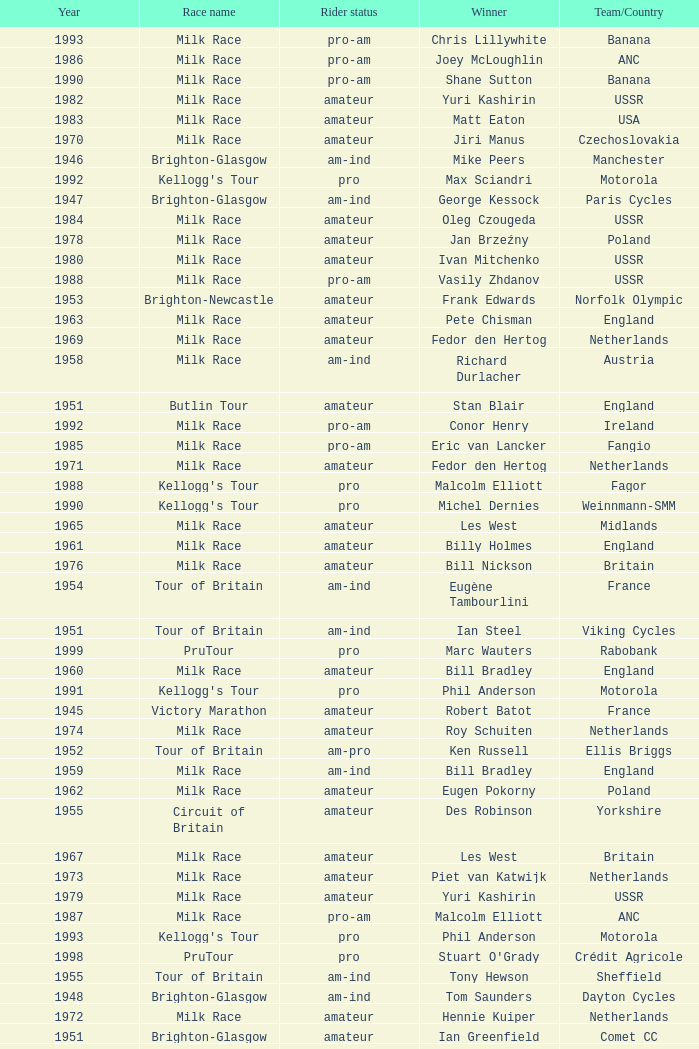What is the rider status for the 1971 netherlands team? Amateur. 